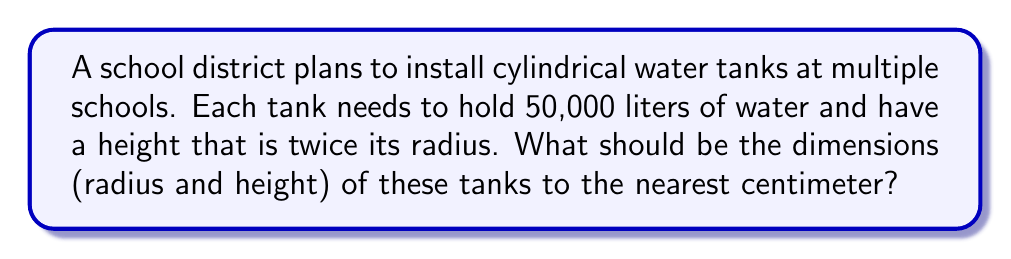Can you answer this question? Let's approach this step-by-step:

1) The volume of a cylinder is given by the formula:
   $$V = \pi r^2 h$$
   where $V$ is volume, $r$ is radius, and $h$ is height.

2) We're told that the height is twice the radius, so:
   $$h = 2r$$

3) Substituting this into our volume formula:
   $$V = \pi r^2 (2r) = 2\pi r^3$$

4) We know the volume is 50,000 liters. We need to convert this to cubic centimeters:
   $$50,000 \text{ L} = 50,000,000 \text{ cm}^3$$

5) Now we can set up our equation:
   $$50,000,000 = 2\pi r^3$$

6) Solving for $r$:
   $$r^3 = \frac{50,000,000}{2\pi} \approx 7,957,747.15$$
   $$r = \sqrt[3]{7,957,747.15} \approx 199.47 \text{ cm}$$

7) Rounding to the nearest centimeter:
   $$r = 199 \text{ cm}$$

8) The height is twice the radius:
   $$h = 2r = 2(199) = 398 \text{ cm}$$

Therefore, the dimensions should be:
Radius: 199 cm
Height: 398 cm
Answer: $r = 199 \text{ cm}, h = 398 \text{ cm}$ 